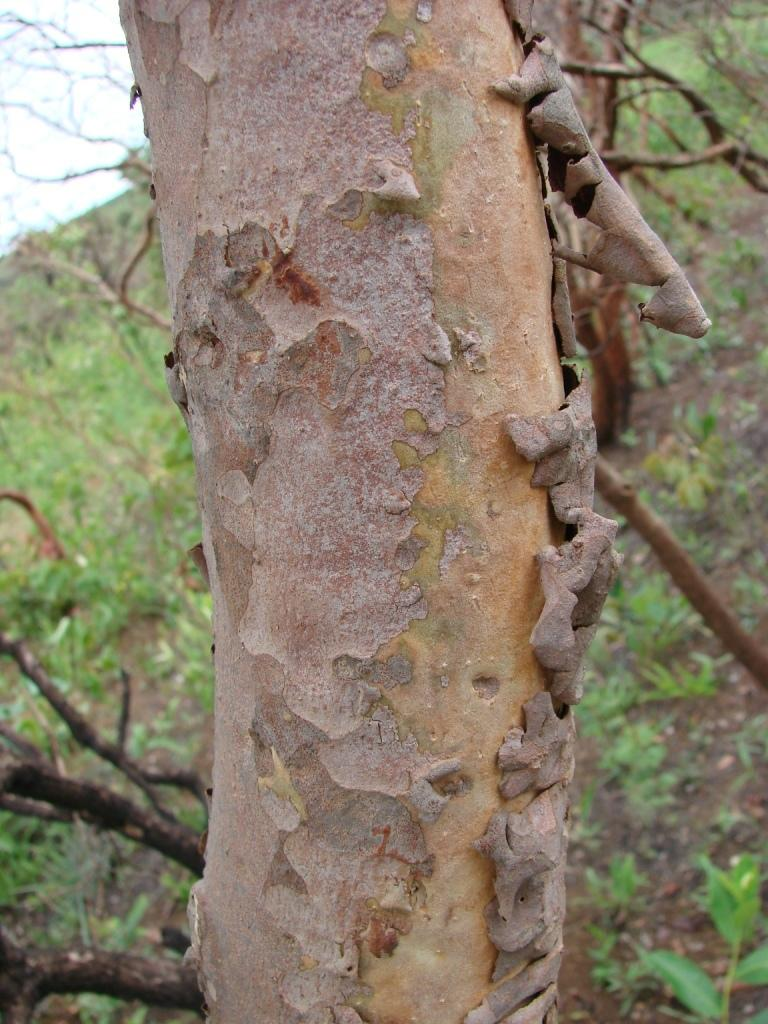What is the main subject of the image? The main subject of the image is a tree trunk. How is the background of the image depicted? The background of the image is slightly blurred. What can be seen in the distance in the image? Trees on the hills and the sky are visible in the background. How many clams are attached to the tree trunk in the image? There are no clams present in the image; it features a tree trunk and a blurred background. What type of toothbrush is hanging from the tree trunk in the image? There is no toothbrush present in the image; it only shows a tree trunk and a blurred background. 